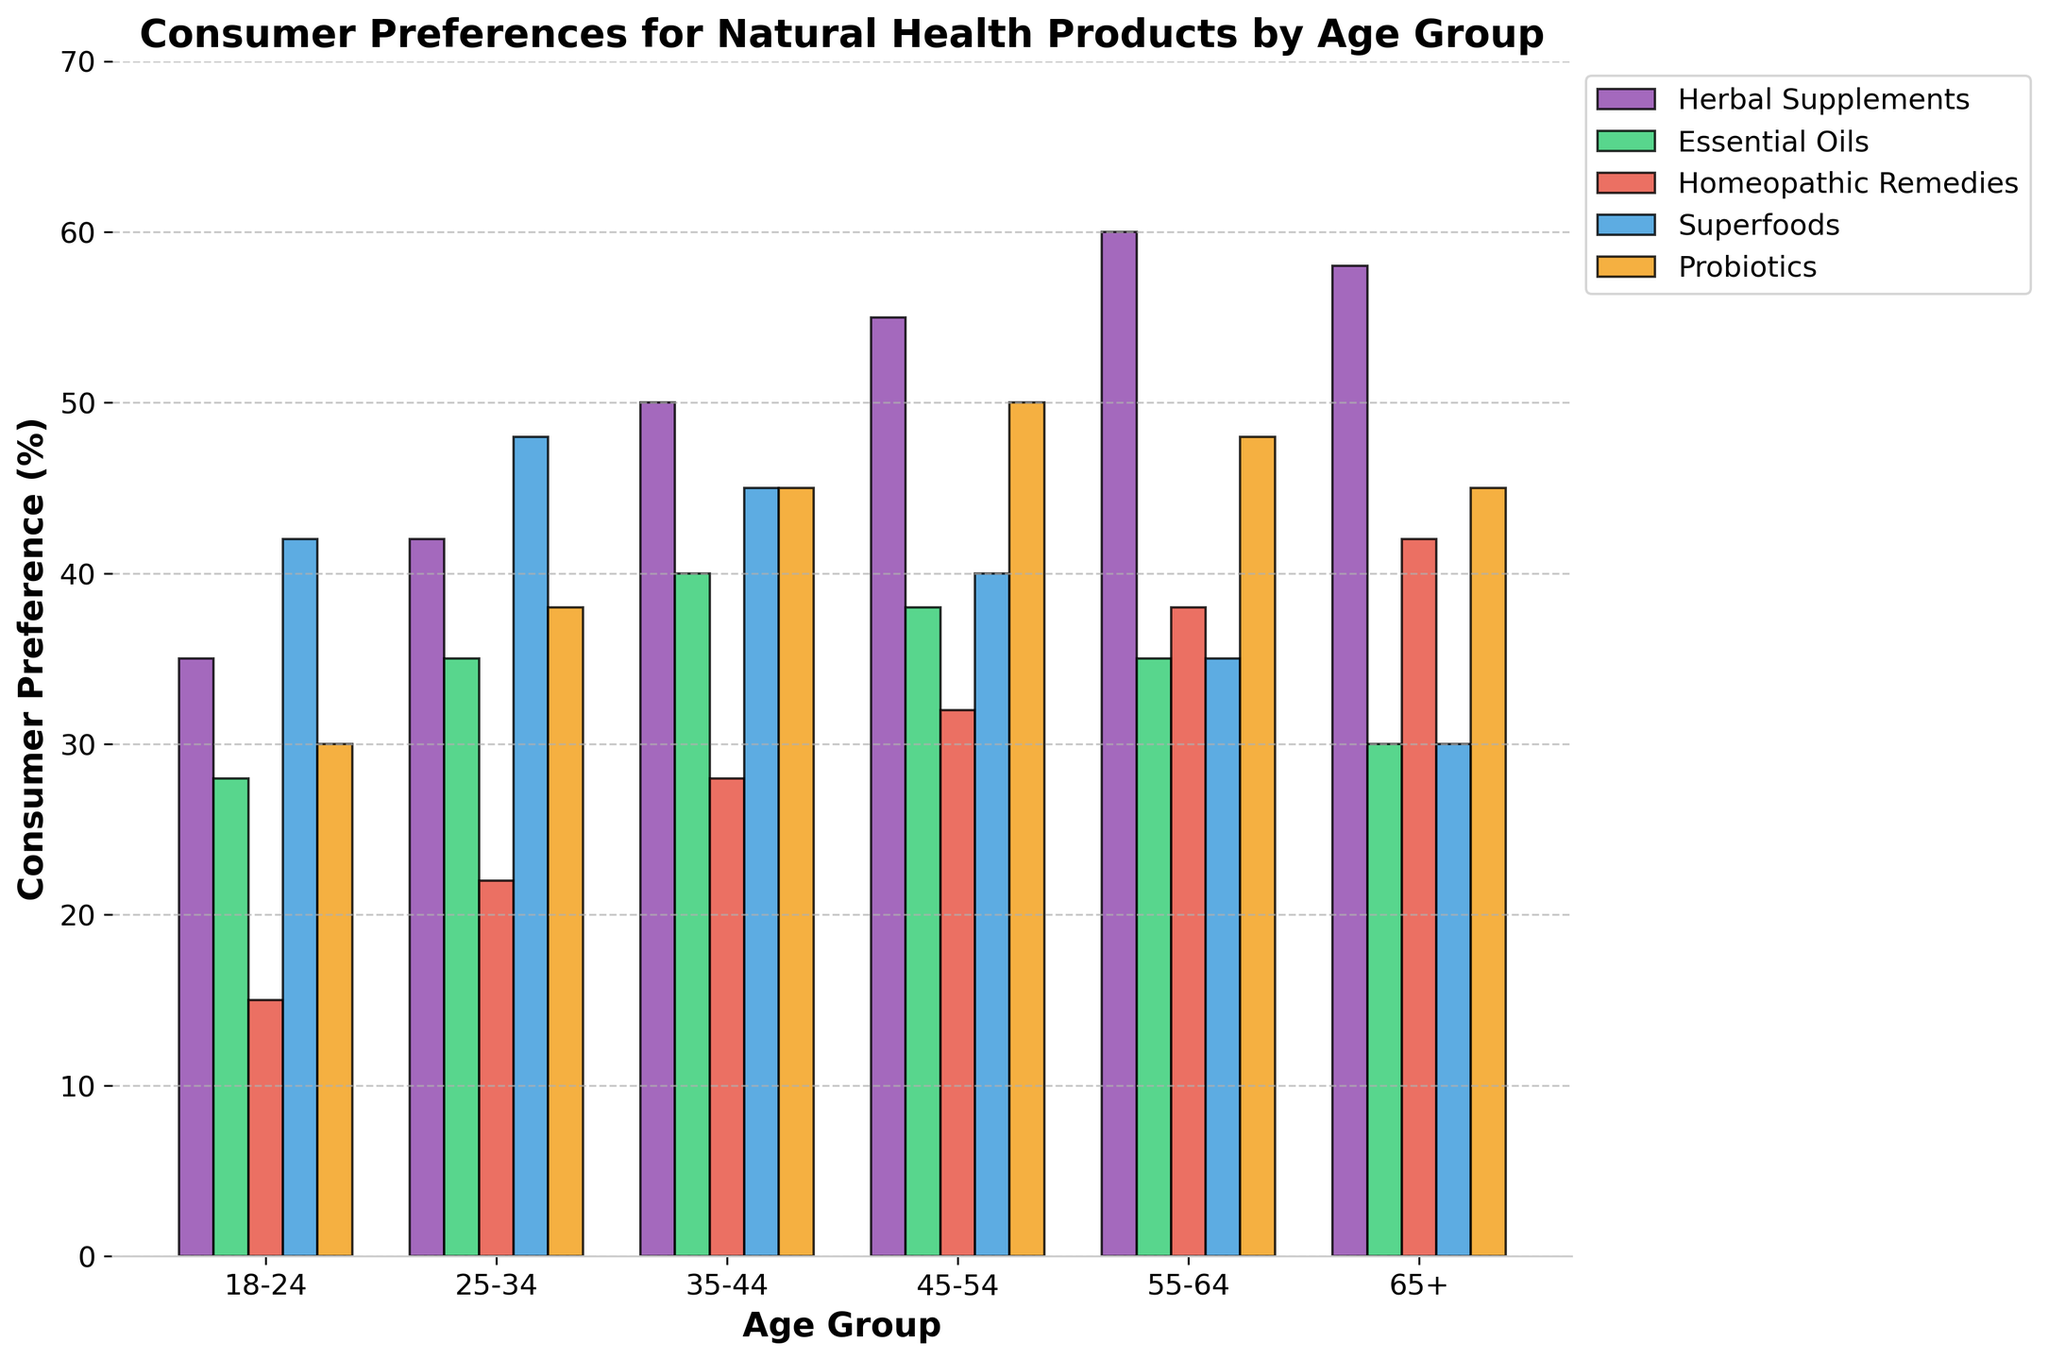Which age group has the highest preference for probiotics? To find the answer, look at the bars representing probiotics in different age groups. The tallest bar corresponds to the 45-54 age group, showing the highest preference.
Answer: 45-54 How does the preference for superfoods change from the 18-24 age group to the 65+ age group? Compare the height of the superfoods bars for the 18-24 and 65+ age groups. The 18-24 group has 42%, whereas the 65+ group has 30%. So, preference decreases.
Answer: Decreases What's the average preference for essential oils across all age groups? Add the percentages for essential oils across all groups (28 + 35 + 40 + 38 + 35 + 30) and divide by the number of groups (6). (28 + 35 + 40 + 38 + 35 + 30) / 6 = 34.33%.
Answer: 34.33% Which product is most preferred by the 55-64 age group? Look at the bars for all products within the 55-64 age group. The tallest bar is for herbal supplements, showing the highest preference in this group.
Answer: Herbal Supplements Is there any age group where the preference for homeopathic remedies is higher than essential oils? Compare the height of the bars for homeopathic remedies and essential oils within each age group. In the 65+ group, homeopathic remedies (42%) are preferred more than essential oils (30%).
Answer: 65+ group Which product shows a declining preference trend as age increases? Look at each product's bars across age groups and identify the one whose bars generally decrease in height. Essential oils show a general declining trend from 18-24 (28%) to 65+ (30%).
Answer: Essential Oils How does the preference for probiotics compare between the 25-34 and 55-64 age groups? Compare the height of the probiotics bar for both age groups. The 25-34 age group has 38%, while the 55-64 age group has 48%, showing an increase.
Answer: Higher in 55-64 What's the difference in preference for herbal supplements between the 35-44 and 45-54 age groups? Find the percentages for herbal supplements for both age groups (50% for 35-44 and 55% for 45-54) and calculate the difference: 55 - 50 = 5%.
Answer: 5% Which age group has the least preference for homeopathic remedies, and what is the percentage? Identify the shortest bar in the homeopathic remedies category; it is the 18-24 group with 15%.
Answer: 18-24, 15% Do preferences for any of the products peak in the same age group? Scan the chart for multiple products reaching their highest percentage within the same age group. Both herbal supplements (60%) and homeopathic remedies (42%) peak within the 55-64 age group.
Answer: Yes, 55-64 